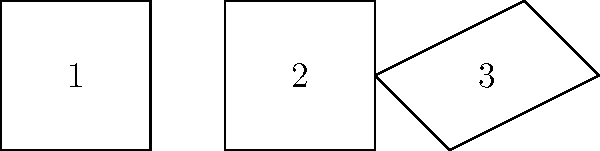In your new publishing company, you're evaluating different book cover designs. Which of the shapes above are congruent and could potentially be used interchangeably in your cover layouts? To determine which shapes are congruent, we need to analyze their properties:

1. Shape 1:
   - It's a square with all sides equal and all angles 90°.
   - Side length = 2 units

2. Shape 2:
   - It's also a square with all sides equal and all angles 90°.
   - Side length = 2 units

3. Shape 3:
   - It's a quadrilateral, but not a square or rectangle.
   - It has unequal sides and angles that are not 90°.

Comparing the shapes:
- Shapes 1 and 2 are both squares with the same side length (2 units).
- Shape 3 is different from both 1 and 2 in terms of side lengths and angles.

For two shapes to be congruent, they must have the same shape and size. This means all corresponding sides must be equal, and all corresponding angles must be equal.

Therefore, shapes 1 and 2 are congruent to each other, as they are both squares with the same dimensions. Shape 3 is not congruent to either 1 or 2.
Answer: Shapes 1 and 2 